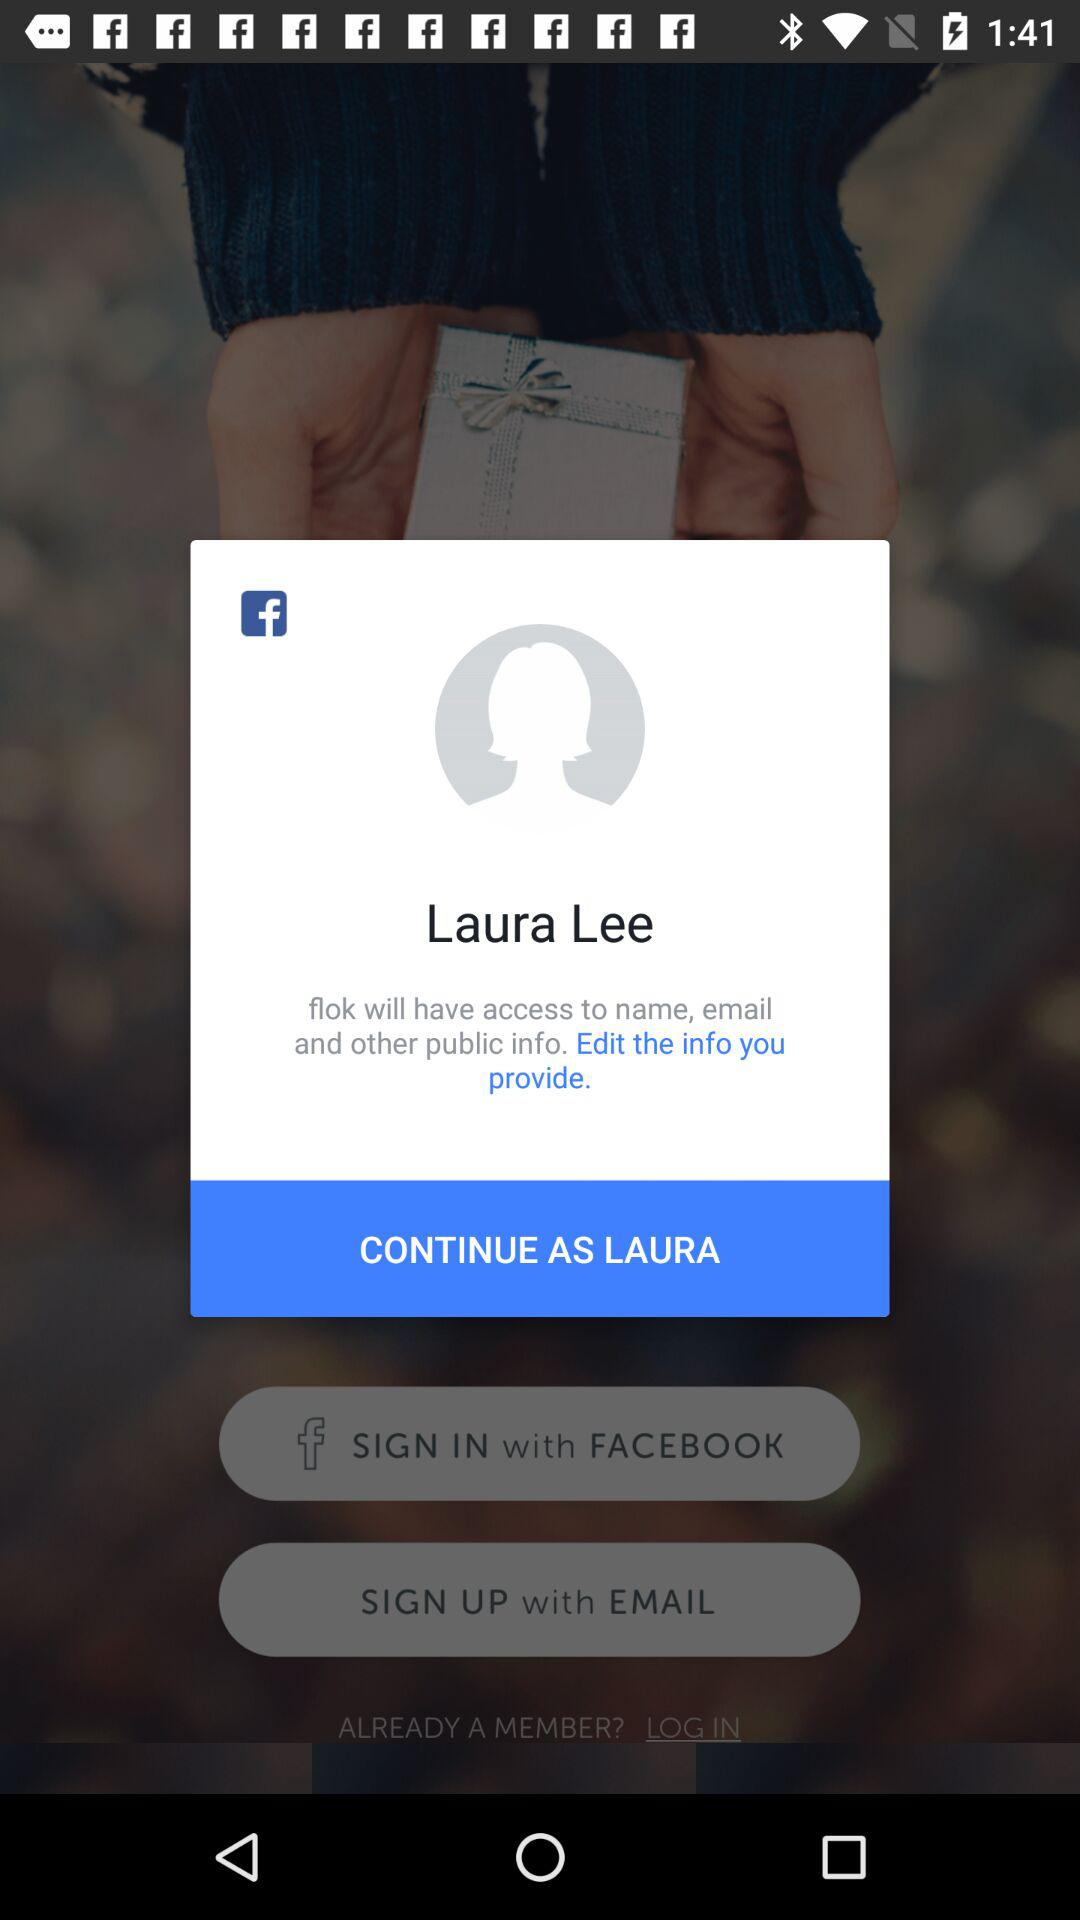What application will have access to my name and other public information? The application that will have access to your name and other public information is "flok". 